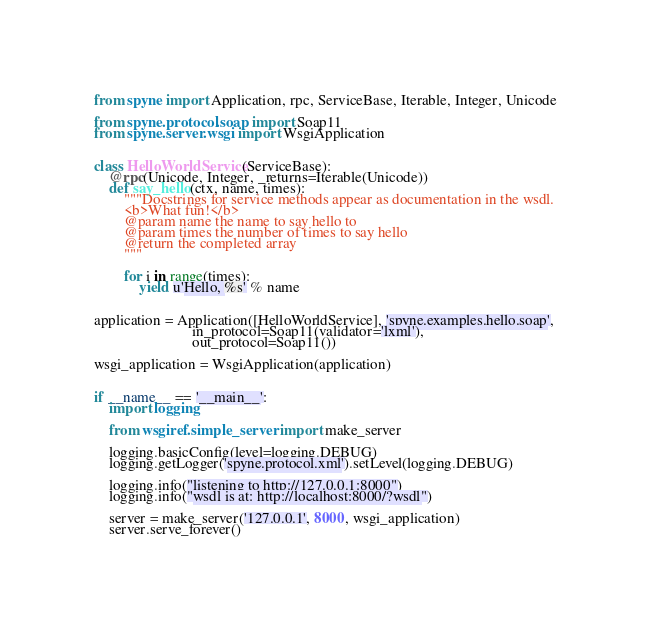<code> <loc_0><loc_0><loc_500><loc_500><_Python_>from spyne import Application, rpc, ServiceBase, Iterable, Integer, Unicode

from spyne.protocol.soap import Soap11
from spyne.server.wsgi import WsgiApplication


class HelloWorldService(ServiceBase):
    @rpc(Unicode, Integer, _returns=Iterable(Unicode))
    def say_hello(ctx, name, times):
        """Docstrings for service methods appear as documentation in the wsdl.
        <b>What fun!</b>
        @param name the name to say hello to
        @param times the number of times to say hello
        @return the completed array
        """

        for i in range(times):
            yield u'Hello, %s' % name


application = Application([HelloWorldService], 'spyne.examples.hello.soap',
                          in_protocol=Soap11(validator='lxml'),
                          out_protocol=Soap11())

wsgi_application = WsgiApplication(application)


if __name__ == '__main__':
    import logging

    from wsgiref.simple_server import make_server

    logging.basicConfig(level=logging.DEBUG)
    logging.getLogger('spyne.protocol.xml').setLevel(logging.DEBUG)

    logging.info("listening to http://127.0.0.1:8000")
    logging.info("wsdl is at: http://localhost:8000/?wsdl")

    server = make_server('127.0.0.1', 8000, wsgi_application)
    server.serve_forever()
</code> 